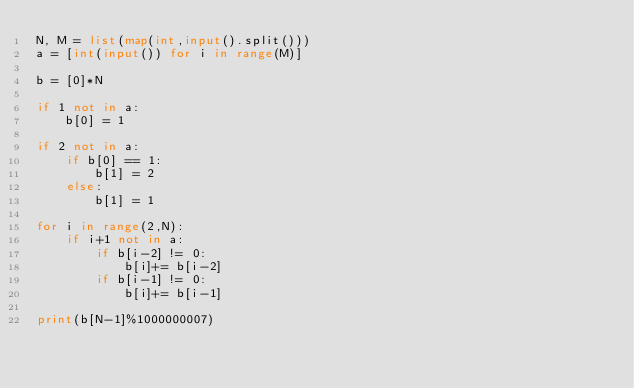Convert code to text. <code><loc_0><loc_0><loc_500><loc_500><_Python_>N, M = list(map(int,input().split()))
a = [int(input()) for i in range(M)]

b = [0]*N

if 1 not in a:
    b[0] = 1

if 2 not in a:
    if b[0] == 1:
        b[1] = 2
    else:
        b[1] = 1

for i in range(2,N):
    if i+1 not in a:
        if b[i-2] != 0:
            b[i]+= b[i-2]
        if b[i-1] != 0:
            b[i]+= b[i-1]

print(b[N-1]%1000000007)</code> 